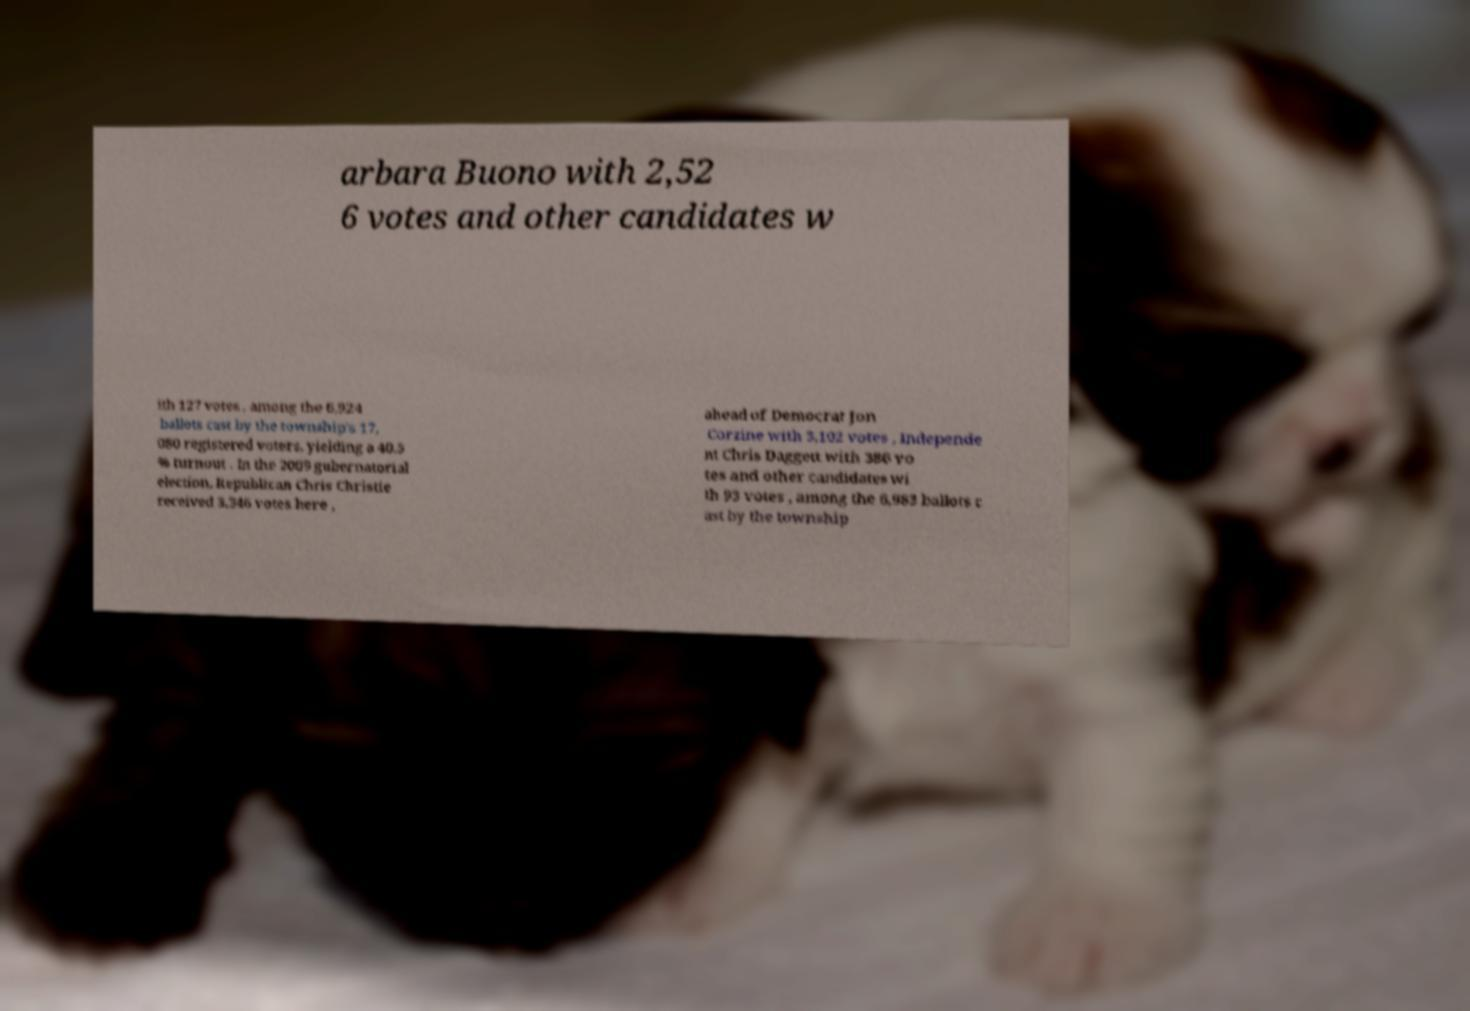Can you accurately transcribe the text from the provided image for me? arbara Buono with 2,52 6 votes and other candidates w ith 127 votes , among the 6,924 ballots cast by the township's 17, 080 registered voters, yielding a 40.5 % turnout . In the 2009 gubernatorial election, Republican Chris Christie received 3,346 votes here , ahead of Democrat Jon Corzine with 3,102 votes , Independe nt Chris Daggett with 386 vo tes and other candidates wi th 93 votes , among the 6,983 ballots c ast by the township 